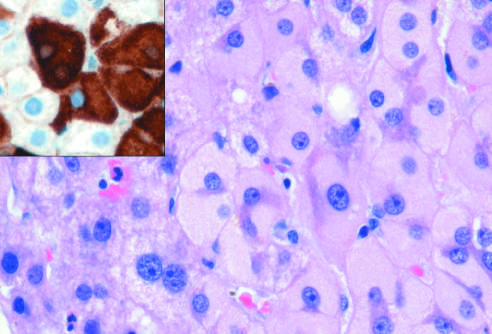does immunostaining with a specific antibody confirm the presence of surface antigen brown?
Answer the question using a single word or phrase. Yes 